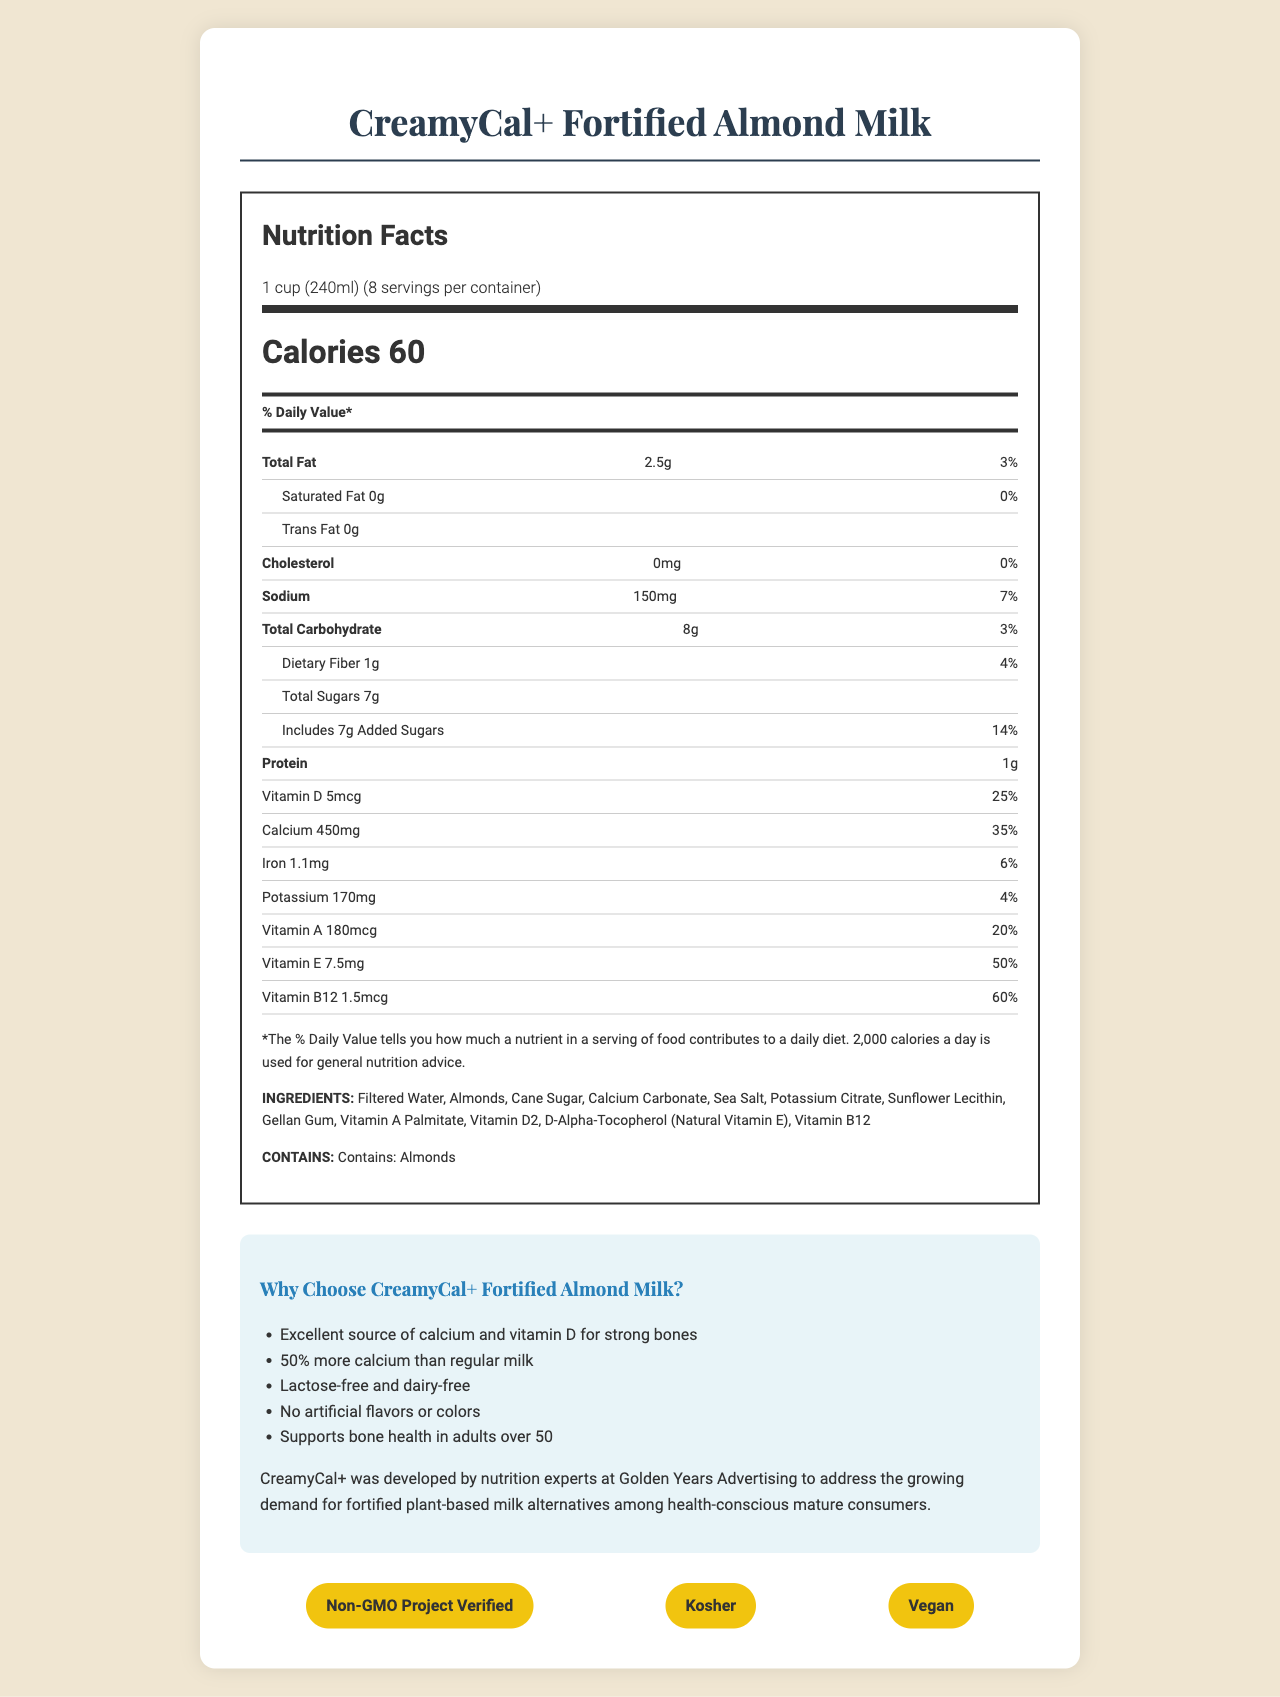what is the serving size of CreamyCal+ Fortified Almond Milk? The serving size is listed clearly under the product name as "1 cup (240ml)".
Answer: 1 cup (240ml) how many calories are in one serving of CreamyCal+ Fortified Almond Milk? The document lists the calories per serving in bold as "Calories 60".
Answer: 60 calories what is the percentage daily value of calcium per serving? Under the nutrition facts, it states "Calcium 450mg 35%".
Answer: 35% what is the total amount of sugars per serving and how much of it is added sugar? The document lists "Total Sugars 7g" and "Includes 7g Added Sugars".
Answer: Total sugars 7g, Includes 7g added sugars what vitamins and minerals are in CreamyCal+ Fortified Almond Milk? The document lists these nutrients under the nutrition facts.
Answer: Vitamin D, Calcium, Iron, Potassium, Vitamin A, Vitamin E, Vitamin B12 which statement about CreamyCal+ Fortified Almond Milk is NOT true? A. It is only partially fortified. B. It is lactose-free and dairy-free. C. It has no artificial flavors or colors. The document includes several marketing claims, one of which states that the product is an "excellent source of calcium and vitamin D" implying full fortification.
Answer: A how much Vitamin E does one serving contain? A. 3.5mg B. 7.5mg C. 10mg D. 15mg The nutrition facts section lists "Vitamin E 7.5mg (50%)".
Answer: B does CreamyCal+ Fortified Almond Milk contain any artificial flavors or colors? One of the marketing claims specifically states "No artificial flavors or colors".
Answer: No is CreamyCal+ Fortified Almond Milk suitable for vegans? The product is certified as vegan according to the certifications listed.
Answer: Yes what allergens are present in CreamyCal+ Fortified Almond Milk? The allergen information section states "Contains: Almonds".
Answer: Almonds what is the main idea of the CreamyCal+ Fortified Almond Milk document? The document highlights the product's nutrition facts, such as vitamins and minerals, marketing claims about its health benefits, history, and certifications.
Answer: The main idea is to present the nutritional benefits and marketing claims of CreamyCal+ Fortified Almond Milk, emphasizing its fortification with vitamins and minerals, its suitability for health-conscious mature consumers, and its various certifications. how many servings are there per container? The serving information under the nutrition facts lists "8 servings per container".
Answer: 8 can you find information about the production process of CreamyCal+ Fortified Almond Milk in the document? The document does not provide any details about the production process.
Answer: Cannot be determined 